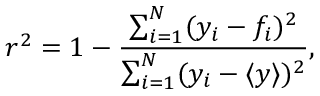<formula> <loc_0><loc_0><loc_500><loc_500>r ^ { 2 } = 1 - \frac { \sum _ { i = 1 } ^ { N } ( y _ { i } - f _ { i } ) ^ { 2 } } { \sum _ { i = 1 } ^ { N } ( y _ { i } - \langle y \rangle ) ^ { 2 } } ,</formula> 